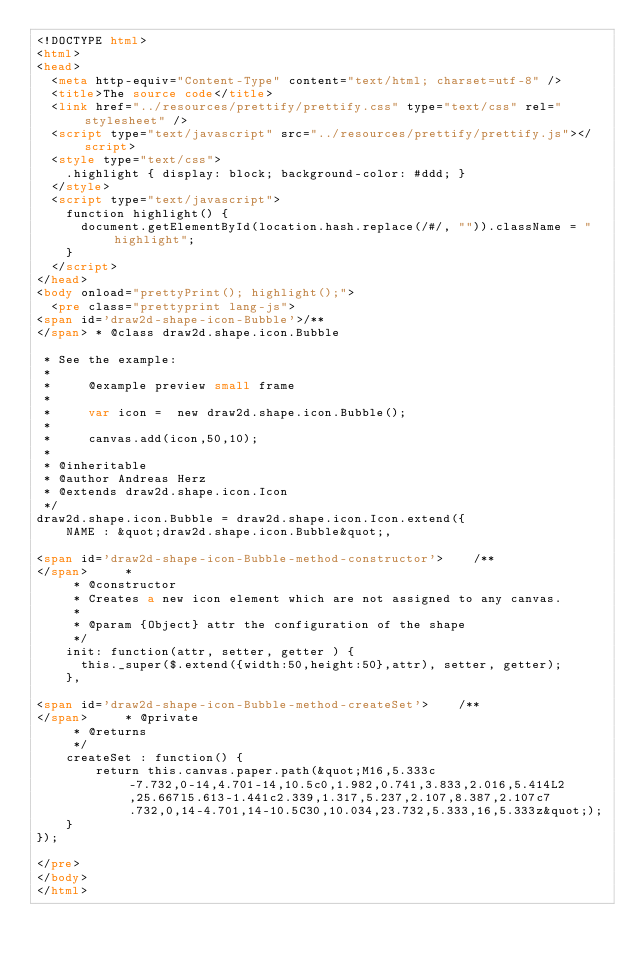<code> <loc_0><loc_0><loc_500><loc_500><_HTML_><!DOCTYPE html>
<html>
<head>
  <meta http-equiv="Content-Type" content="text/html; charset=utf-8" />
  <title>The source code</title>
  <link href="../resources/prettify/prettify.css" type="text/css" rel="stylesheet" />
  <script type="text/javascript" src="../resources/prettify/prettify.js"></script>
  <style type="text/css">
    .highlight { display: block; background-color: #ddd; }
  </style>
  <script type="text/javascript">
    function highlight() {
      document.getElementById(location.hash.replace(/#/, "")).className = "highlight";
    }
  </script>
</head>
<body onload="prettyPrint(); highlight();">
  <pre class="prettyprint lang-js">
<span id='draw2d-shape-icon-Bubble'>/**
</span> * @class draw2d.shape.icon.Bubble

 * See the example:
 *
 *     @example preview small frame
 *     
 *     var icon =  new draw2d.shape.icon.Bubble();
 *     
 *     canvas.add(icon,50,10);
 *     
 * @inheritable
 * @author Andreas Herz
 * @extends draw2d.shape.icon.Icon
 */
draw2d.shape.icon.Bubble = draw2d.shape.icon.Icon.extend({
    NAME : &quot;draw2d.shape.icon.Bubble&quot;,

<span id='draw2d-shape-icon-Bubble-method-constructor'>    /**
</span>     * 
     * @constructor
     * Creates a new icon element which are not assigned to any canvas.
     * 
     * @param {Object} attr the configuration of the shape
     */
    init: function(attr, setter, getter ) {
      this._super($.extend({width:50,height:50},attr), setter, getter);
    },

<span id='draw2d-shape-icon-Bubble-method-createSet'>    /**
</span>     * @private
     * @returns
     */
    createSet : function() {
        return this.canvas.paper.path(&quot;M16,5.333c-7.732,0-14,4.701-14,10.5c0,1.982,0.741,3.833,2.016,5.414L2,25.667l5.613-1.441c2.339,1.317,5.237,2.107,8.387,2.107c7.732,0,14-4.701,14-10.5C30,10.034,23.732,5.333,16,5.333z&quot;);
    }
});

</pre>
</body>
</html>
</code> 